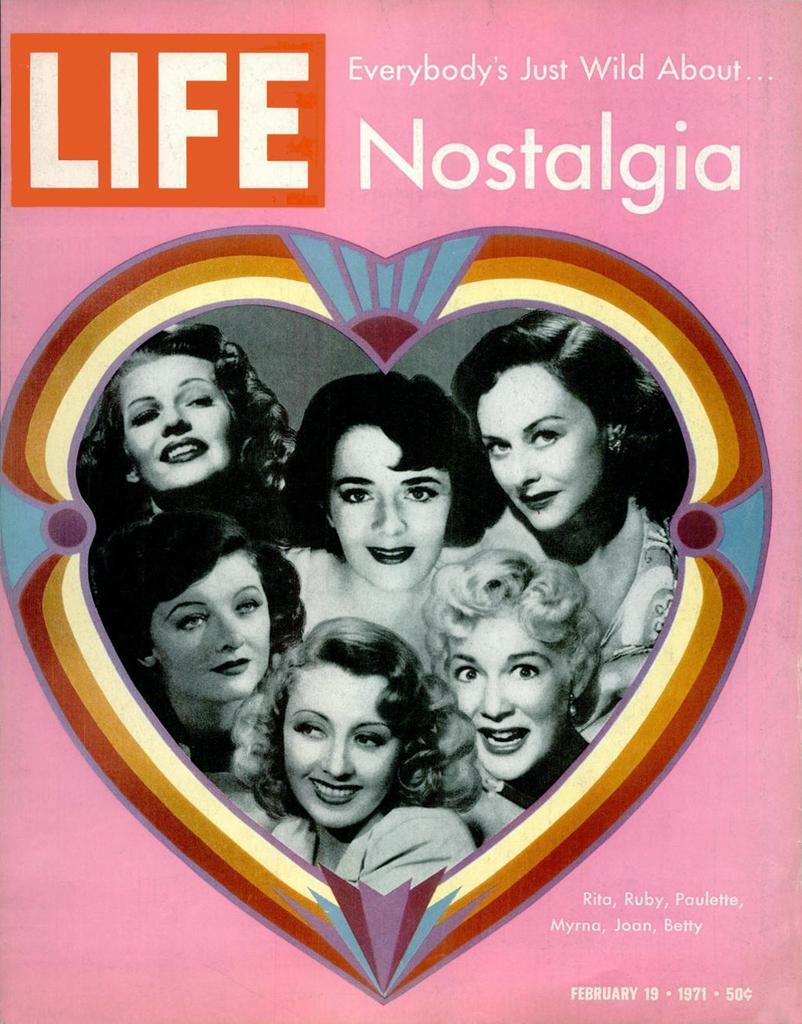How would you summarize this image in a sentence or two? In this image there is a poster, in that poster there are six women photos, at the top there is a text, in the bottom right there is text. 